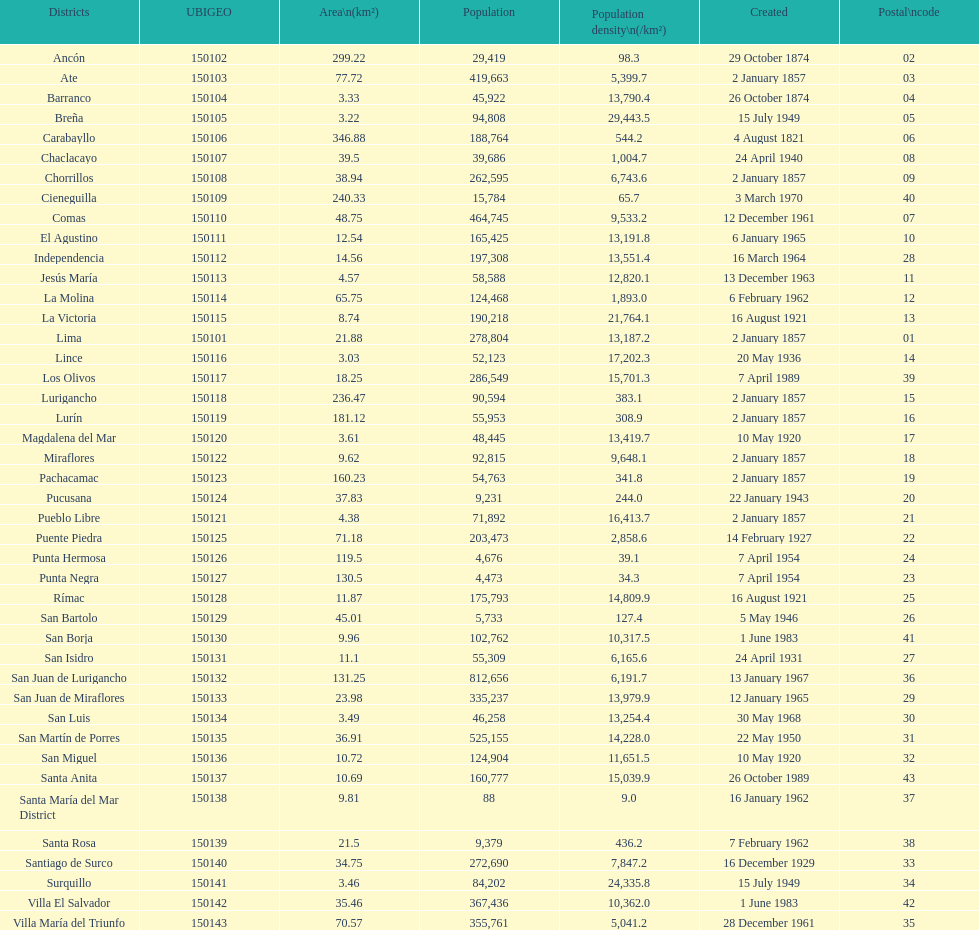How many districts have a population density of at lest 1000.0? 31. 